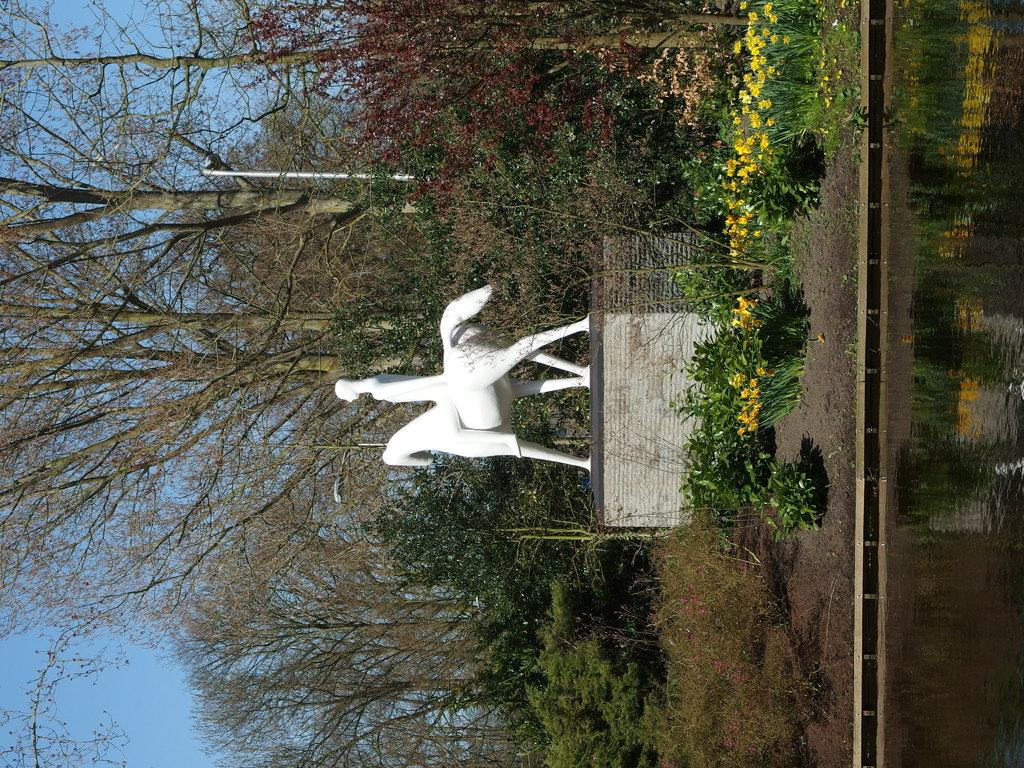What is the main subject in the image? There is a sculpture in the image. What is surrounding the sculpture? Plants and trees are present around the sculpture. What can be seen on the right side of the image? There is water on the right side of the image. How many pigs are visible in the image? There are no pigs present in the image. What type of paper is being used to create the sculpture? The sculpture is not made of paper, and there is no paper visible in the image. 